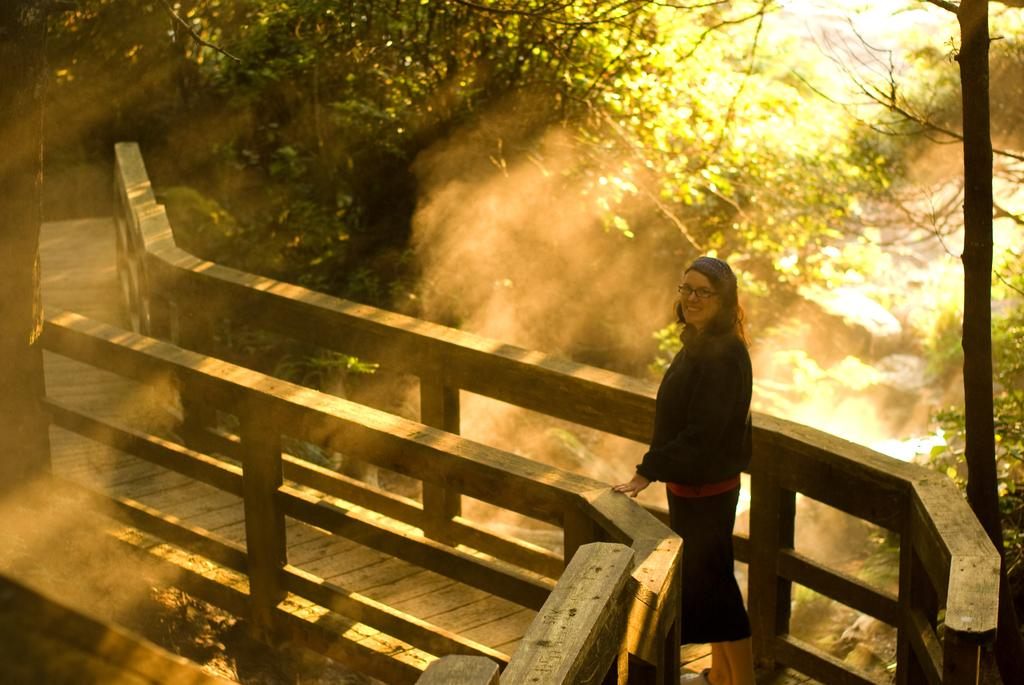Who is present in the image? There is a woman in the image. What is the woman wearing? The woman is wearing a black dress. Where is the woman standing? The woman is standing on a wooden bridge. What can be seen on the bridge? There is wooden railing in the image. What is visible in the background of the image? Trees and rocks are visible in the background of the image. What type of lunch is the woman eating in the image? There is no indication in the image that the woman is eating lunch, so it cannot be determined from the picture. 